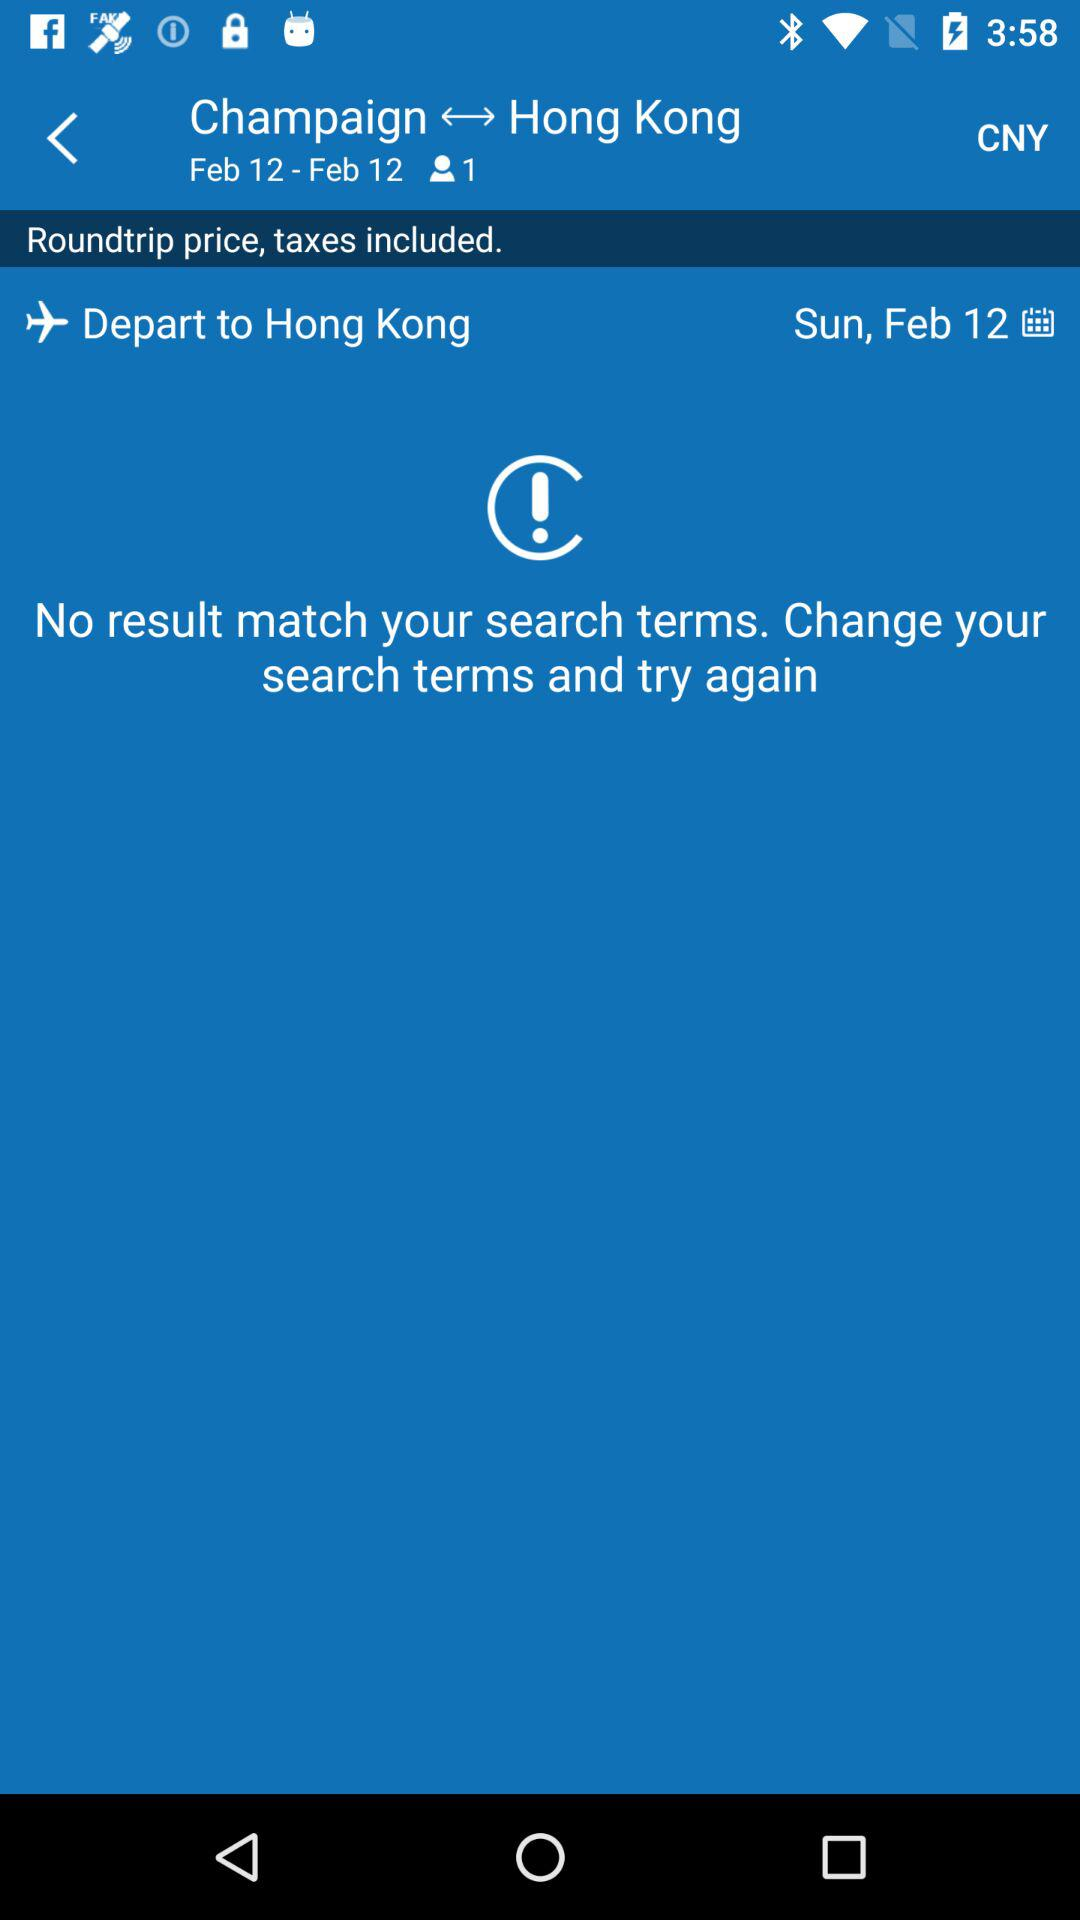Is the search for a round trip?
When the provided information is insufficient, respond with <no answer>. <no answer> 